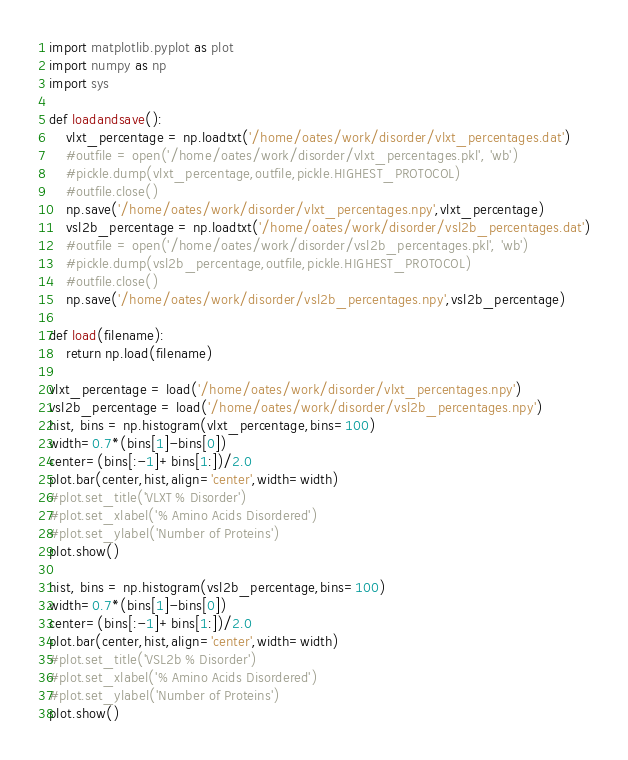<code> <loc_0><loc_0><loc_500><loc_500><_Python_>import matplotlib.pyplot as plot
import numpy as np
import sys

def loadandsave():
    vlxt_percentage = np.loadtxt('/home/oates/work/disorder/vlxt_percentages.dat')
    #outfile = open('/home/oates/work/disorder/vlxt_percentages.pkl', 'wb')
    #pickle.dump(vlxt_percentage,outfile,pickle.HIGHEST_PROTOCOL)
    #outfile.close()
    np.save('/home/oates/work/disorder/vlxt_percentages.npy',vlxt_percentage)
    vsl2b_percentage = np.loadtxt('/home/oates/work/disorder/vsl2b_percentages.dat')
    #outfile = open('/home/oates/work/disorder/vsl2b_percentages.pkl', 'wb')
    #pickle.dump(vsl2b_percentage,outfile,pickle.HIGHEST_PROTOCOL)
    #outfile.close()
    np.save('/home/oates/work/disorder/vsl2b_percentages.npy',vsl2b_percentage)

def load(filename):
    return np.load(filename)

vlxt_percentage = load('/home/oates/work/disorder/vlxt_percentages.npy')
vsl2b_percentage = load('/home/oates/work/disorder/vsl2b_percentages.npy')
hist, bins = np.histogram(vlxt_percentage,bins=100)
width=0.7*(bins[1]-bins[0])
center=(bins[:-1]+bins[1:])/2.0
plot.bar(center,hist,align='center',width=width)
#plot.set_title('VLXT % Disorder')
#plot.set_xlabel('% Amino Acids Disordered')
#plot.set_ylabel('Number of Proteins')
plot.show()

hist, bins = np.histogram(vsl2b_percentage,bins=100)
width=0.7*(bins[1]-bins[0])
center=(bins[:-1]+bins[1:])/2.0
plot.bar(center,hist,align='center',width=width)
#plot.set_title('VSL2b % Disorder')
#plot.set_xlabel('% Amino Acids Disordered')
#plot.set_ylabel('Number of Proteins')
plot.show()
</code> 